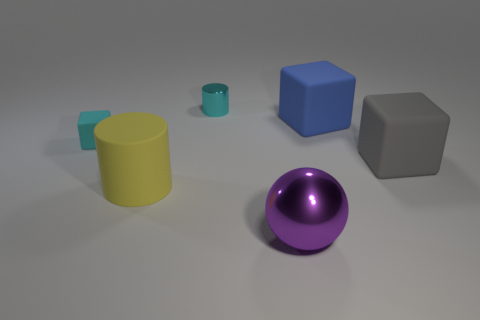Add 2 yellow rubber cylinders. How many objects exist? 8 Subtract all spheres. How many objects are left? 5 Add 3 small cyan shiny cylinders. How many small cyan shiny cylinders are left? 4 Add 4 purple matte things. How many purple matte things exist? 4 Subtract 1 blue blocks. How many objects are left? 5 Subtract all cyan spheres. Subtract all big rubber objects. How many objects are left? 3 